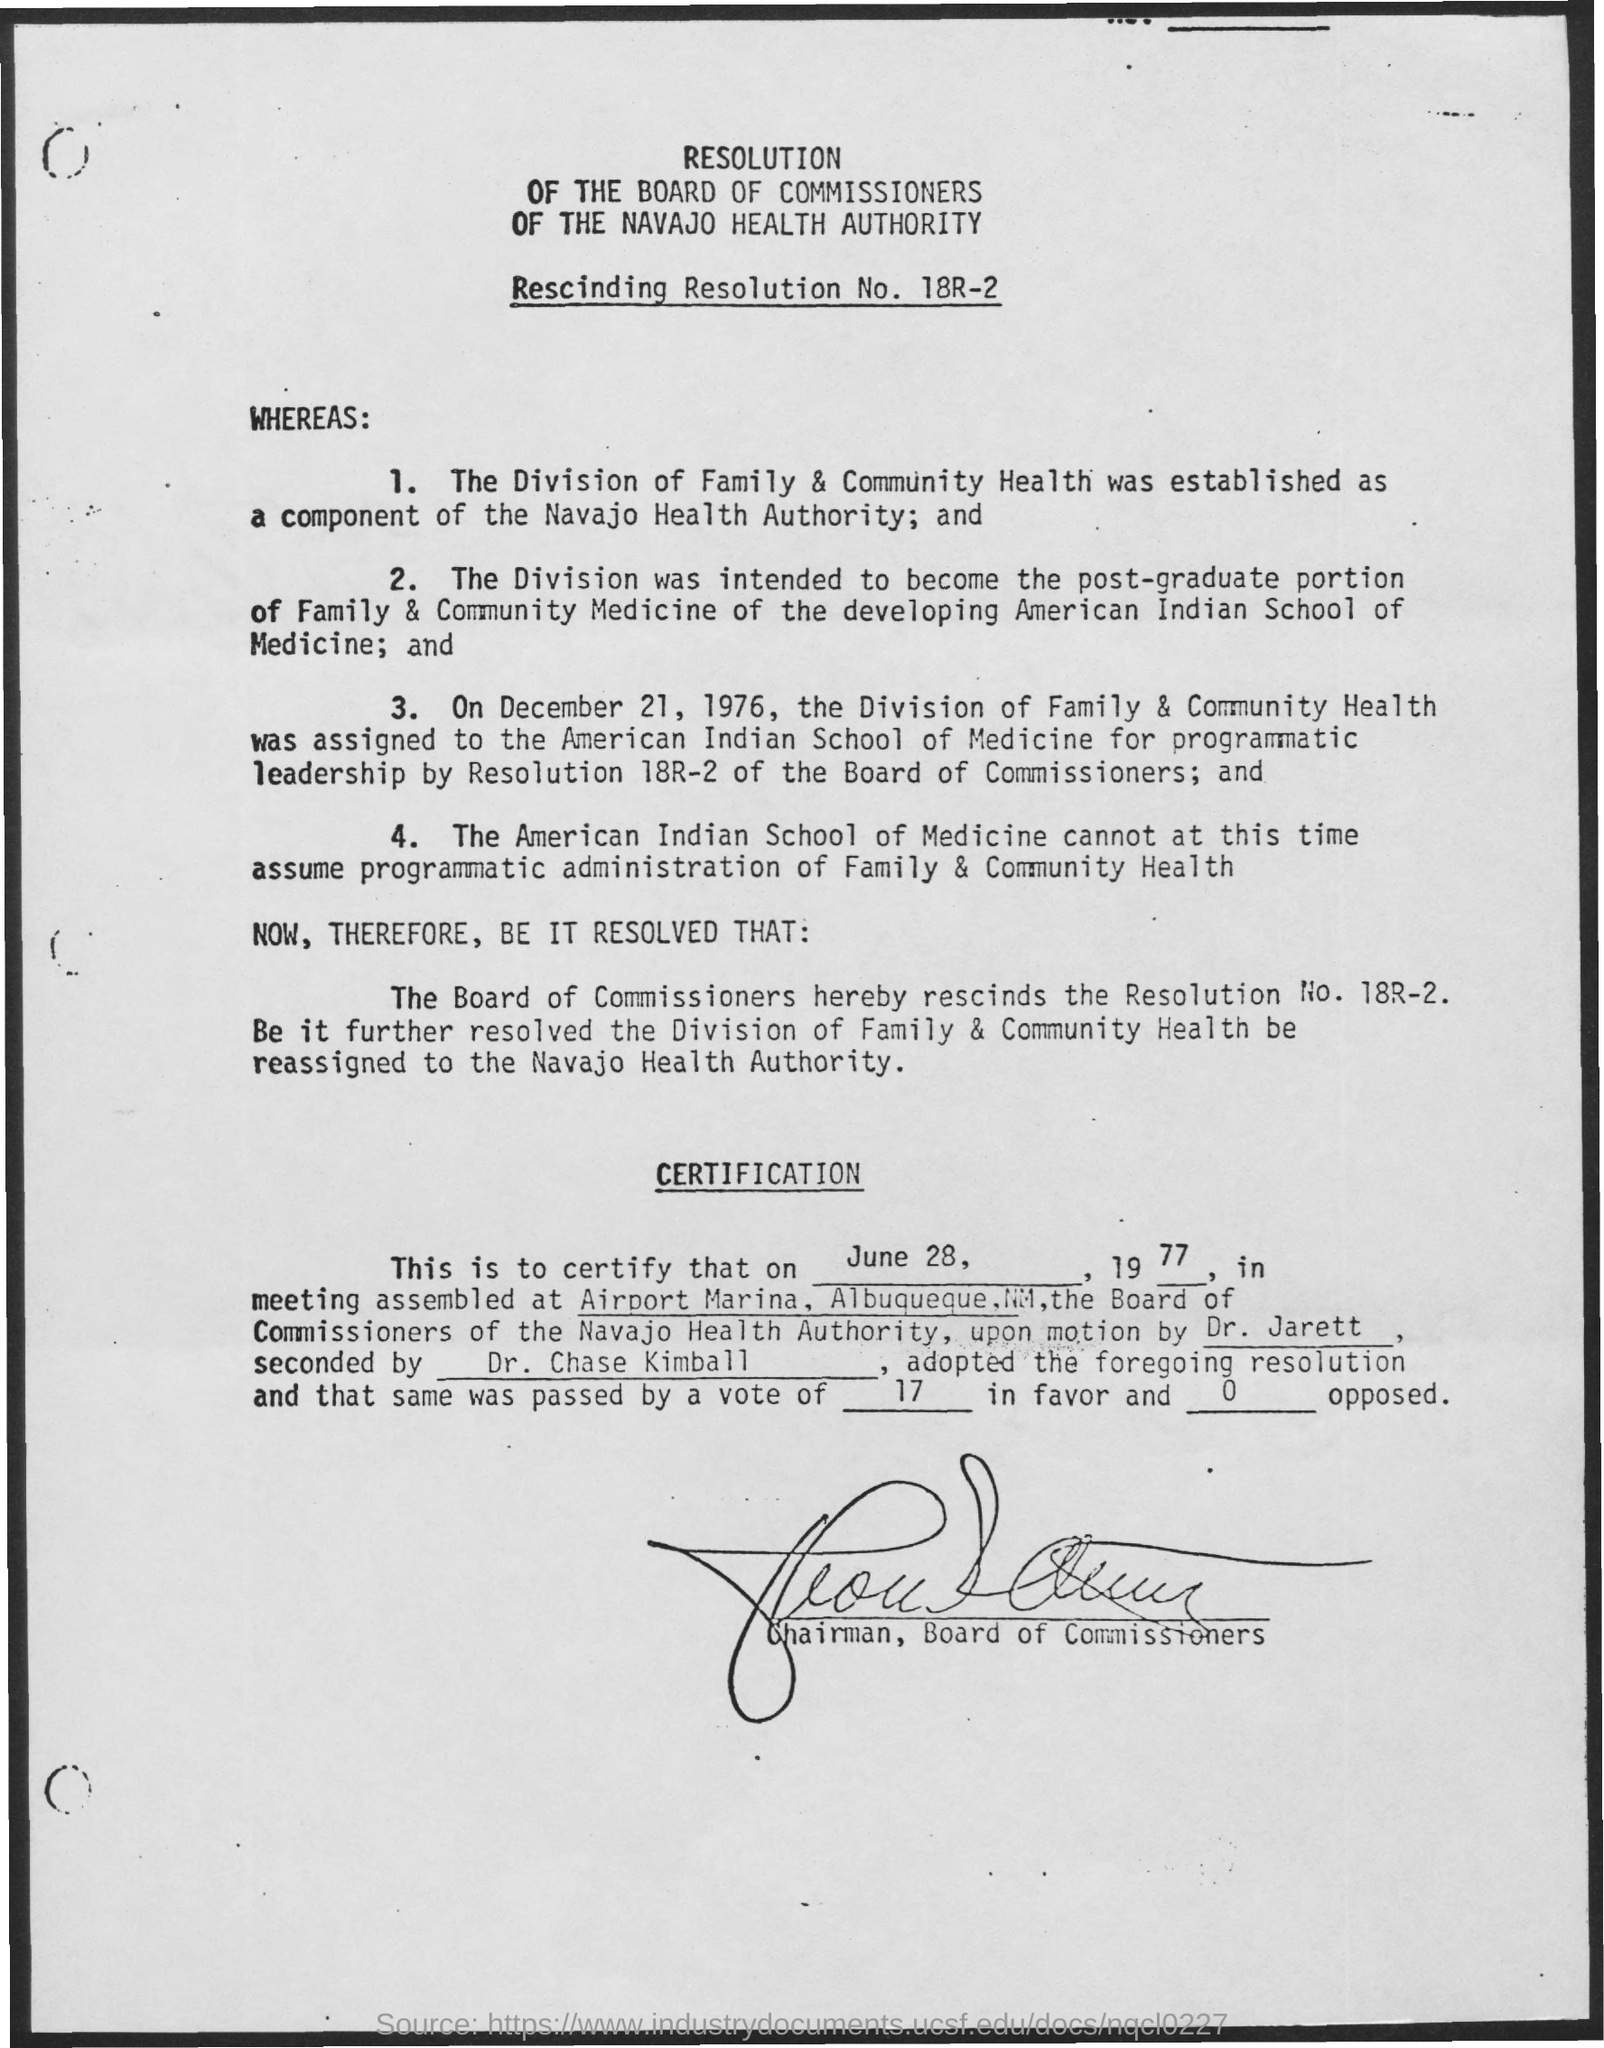The division of Family & community health was estblished as a component of what?
Your answer should be very brief. Navajo Health Authority. 